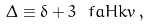<formula> <loc_0><loc_0><loc_500><loc_500>\Delta \equiv \delta + 3 \ f { a H } { k } v \, ,</formula> 